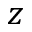<formula> <loc_0><loc_0><loc_500><loc_500>z</formula> 